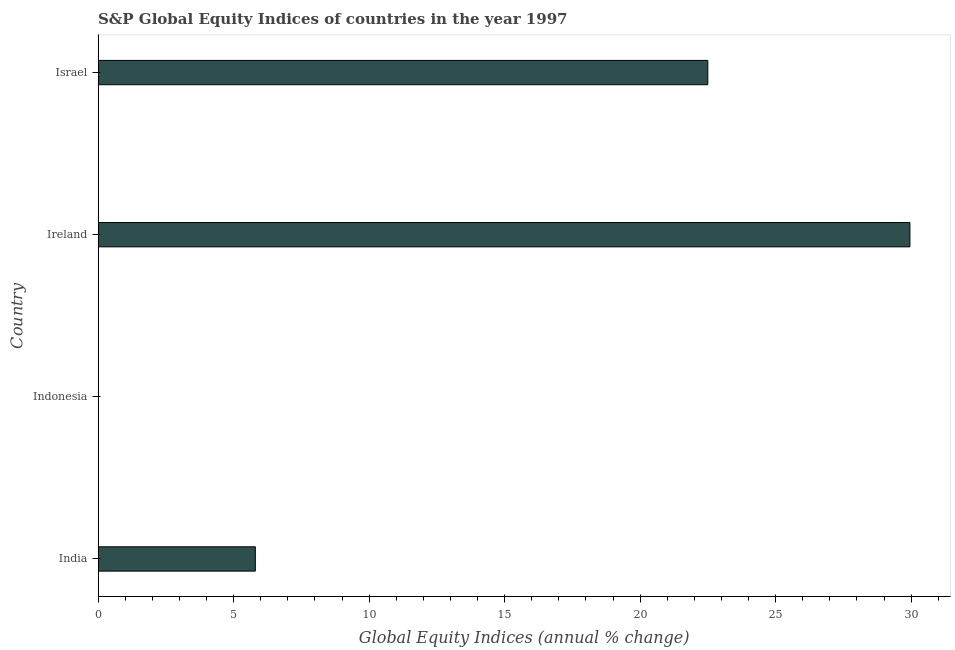Does the graph contain any zero values?
Offer a terse response. Yes. Does the graph contain grids?
Make the answer very short. No. What is the title of the graph?
Provide a succinct answer. S&P Global Equity Indices of countries in the year 1997. What is the label or title of the X-axis?
Make the answer very short. Global Equity Indices (annual % change). What is the s&p global equity indices in Israel?
Your answer should be compact. 22.5. Across all countries, what is the maximum s&p global equity indices?
Offer a terse response. 29.95. In which country was the s&p global equity indices maximum?
Your response must be concise. Ireland. What is the sum of the s&p global equity indices?
Ensure brevity in your answer.  58.25. What is the difference between the s&p global equity indices in India and Ireland?
Keep it short and to the point. -24.15. What is the average s&p global equity indices per country?
Your response must be concise. 14.56. What is the median s&p global equity indices?
Offer a very short reply. 14.15. In how many countries, is the s&p global equity indices greater than 30 %?
Provide a short and direct response. 0. What is the ratio of the s&p global equity indices in Ireland to that in Israel?
Give a very brief answer. 1.33. Is the s&p global equity indices in Ireland less than that in Israel?
Your response must be concise. No. What is the difference between the highest and the second highest s&p global equity indices?
Your answer should be compact. 7.46. Is the sum of the s&p global equity indices in India and Israel greater than the maximum s&p global equity indices across all countries?
Make the answer very short. No. What is the difference between the highest and the lowest s&p global equity indices?
Make the answer very short. 29.95. In how many countries, is the s&p global equity indices greater than the average s&p global equity indices taken over all countries?
Ensure brevity in your answer.  2. How many bars are there?
Provide a succinct answer. 3. How many countries are there in the graph?
Offer a terse response. 4. Are the values on the major ticks of X-axis written in scientific E-notation?
Ensure brevity in your answer.  No. What is the Global Equity Indices (annual % change) of India?
Provide a short and direct response. 5.8. What is the Global Equity Indices (annual % change) of Indonesia?
Make the answer very short. 0. What is the Global Equity Indices (annual % change) of Ireland?
Give a very brief answer. 29.95. What is the Global Equity Indices (annual % change) in Israel?
Offer a terse response. 22.5. What is the difference between the Global Equity Indices (annual % change) in India and Ireland?
Provide a short and direct response. -24.15. What is the difference between the Global Equity Indices (annual % change) in India and Israel?
Your response must be concise. -16.7. What is the difference between the Global Equity Indices (annual % change) in Ireland and Israel?
Offer a terse response. 7.46. What is the ratio of the Global Equity Indices (annual % change) in India to that in Ireland?
Provide a short and direct response. 0.19. What is the ratio of the Global Equity Indices (annual % change) in India to that in Israel?
Give a very brief answer. 0.26. What is the ratio of the Global Equity Indices (annual % change) in Ireland to that in Israel?
Make the answer very short. 1.33. 